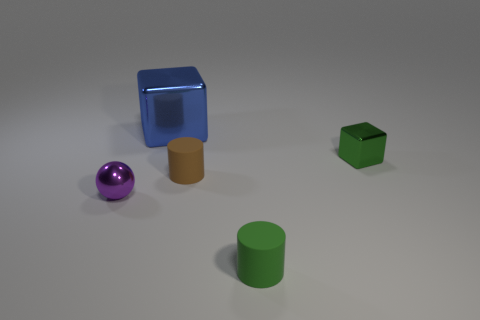Is there a tiny green cube that is on the left side of the rubber thing that is behind the object in front of the ball?
Provide a succinct answer. No. What size is the green block?
Provide a short and direct response. Small. What number of things are blue shiny blocks or shiny objects?
Your answer should be compact. 3. The small block that is made of the same material as the small purple ball is what color?
Give a very brief answer. Green. Do the rubber object in front of the tiny metal ball and the purple thing have the same shape?
Ensure brevity in your answer.  No. How many objects are small metal objects that are to the right of the blue block or metal objects that are right of the small brown thing?
Keep it short and to the point. 1. What is the color of the other thing that is the same shape as the green matte thing?
Make the answer very short. Brown. Is there any other thing that is the same shape as the tiny brown thing?
Your answer should be very brief. Yes. There is a purple object; is its shape the same as the metal object on the right side of the big metal block?
Your answer should be very brief. No. What is the material of the brown cylinder?
Keep it short and to the point. Rubber. 